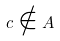<formula> <loc_0><loc_0><loc_500><loc_500>c \notin A</formula> 